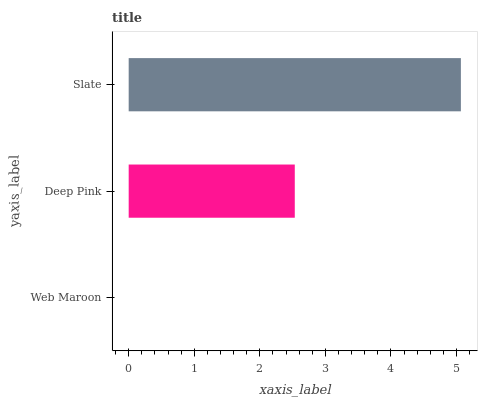Is Web Maroon the minimum?
Answer yes or no. Yes. Is Slate the maximum?
Answer yes or no. Yes. Is Deep Pink the minimum?
Answer yes or no. No. Is Deep Pink the maximum?
Answer yes or no. No. Is Deep Pink greater than Web Maroon?
Answer yes or no. Yes. Is Web Maroon less than Deep Pink?
Answer yes or no. Yes. Is Web Maroon greater than Deep Pink?
Answer yes or no. No. Is Deep Pink less than Web Maroon?
Answer yes or no. No. Is Deep Pink the high median?
Answer yes or no. Yes. Is Deep Pink the low median?
Answer yes or no. Yes. Is Slate the high median?
Answer yes or no. No. Is Web Maroon the low median?
Answer yes or no. No. 